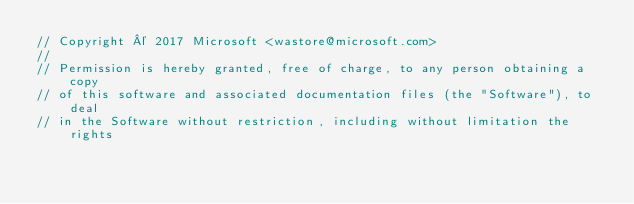<code> <loc_0><loc_0><loc_500><loc_500><_Go_>// Copyright © 2017 Microsoft <wastore@microsoft.com>
//
// Permission is hereby granted, free of charge, to any person obtaining a copy
// of this software and associated documentation files (the "Software"), to deal
// in the Software without restriction, including without limitation the rights</code> 